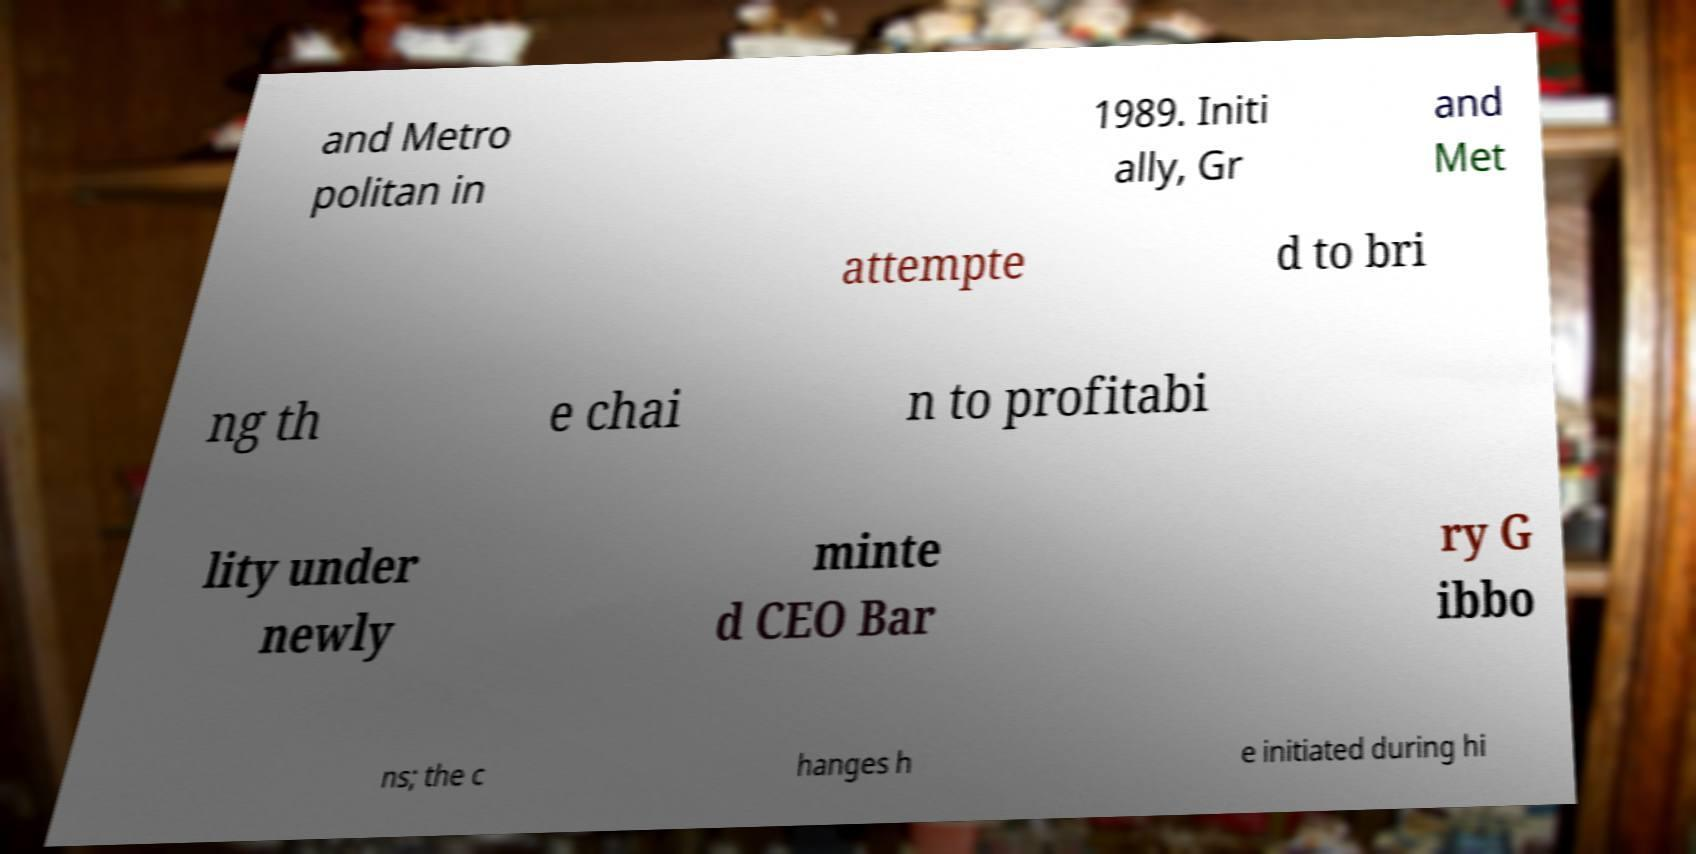Can you read and provide the text displayed in the image?This photo seems to have some interesting text. Can you extract and type it out for me? and Metro politan in 1989. Initi ally, Gr and Met attempte d to bri ng th e chai n to profitabi lity under newly minte d CEO Bar ry G ibbo ns; the c hanges h e initiated during hi 